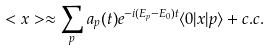<formula> <loc_0><loc_0><loc_500><loc_500>< x > \approx \sum _ { p } a _ { p } ( t ) e ^ { - i ( E _ { p } - E _ { 0 } ) t } \langle 0 | x | { p } \rangle + c . c .</formula> 